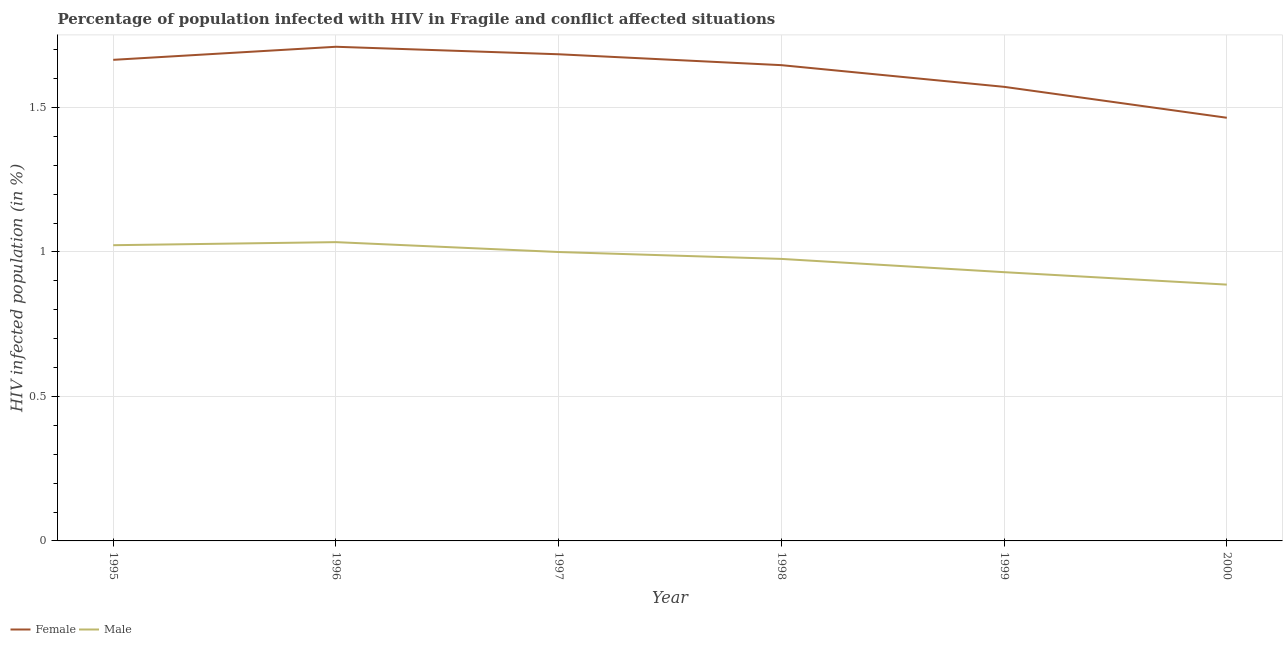How many different coloured lines are there?
Ensure brevity in your answer.  2. Does the line corresponding to percentage of females who are infected with hiv intersect with the line corresponding to percentage of males who are infected with hiv?
Offer a very short reply. No. Is the number of lines equal to the number of legend labels?
Your answer should be very brief. Yes. What is the percentage of males who are infected with hiv in 1998?
Provide a short and direct response. 0.98. Across all years, what is the maximum percentage of males who are infected with hiv?
Your response must be concise. 1.03. Across all years, what is the minimum percentage of males who are infected with hiv?
Your answer should be very brief. 0.89. In which year was the percentage of females who are infected with hiv maximum?
Give a very brief answer. 1996. What is the total percentage of males who are infected with hiv in the graph?
Ensure brevity in your answer.  5.85. What is the difference between the percentage of females who are infected with hiv in 1997 and that in 2000?
Offer a terse response. 0.22. What is the difference between the percentage of males who are infected with hiv in 1999 and the percentage of females who are infected with hiv in 1997?
Offer a terse response. -0.75. What is the average percentage of males who are infected with hiv per year?
Your answer should be very brief. 0.97. In the year 1999, what is the difference between the percentage of females who are infected with hiv and percentage of males who are infected with hiv?
Keep it short and to the point. 0.64. In how many years, is the percentage of females who are infected with hiv greater than 1.4 %?
Your response must be concise. 6. What is the ratio of the percentage of males who are infected with hiv in 1998 to that in 1999?
Give a very brief answer. 1.05. Is the percentage of males who are infected with hiv in 1996 less than that in 2000?
Keep it short and to the point. No. What is the difference between the highest and the second highest percentage of females who are infected with hiv?
Provide a succinct answer. 0.03. What is the difference between the highest and the lowest percentage of males who are infected with hiv?
Give a very brief answer. 0.15. In how many years, is the percentage of males who are infected with hiv greater than the average percentage of males who are infected with hiv taken over all years?
Make the answer very short. 4. Is the percentage of males who are infected with hiv strictly greater than the percentage of females who are infected with hiv over the years?
Your response must be concise. No. What is the difference between two consecutive major ticks on the Y-axis?
Keep it short and to the point. 0.5. Does the graph contain any zero values?
Provide a short and direct response. No. How are the legend labels stacked?
Give a very brief answer. Horizontal. What is the title of the graph?
Offer a terse response. Percentage of population infected with HIV in Fragile and conflict affected situations. What is the label or title of the X-axis?
Keep it short and to the point. Year. What is the label or title of the Y-axis?
Keep it short and to the point. HIV infected population (in %). What is the HIV infected population (in %) of Female in 1995?
Offer a terse response. 1.66. What is the HIV infected population (in %) of Male in 1995?
Keep it short and to the point. 1.02. What is the HIV infected population (in %) of Female in 1996?
Provide a short and direct response. 1.71. What is the HIV infected population (in %) in Male in 1996?
Make the answer very short. 1.03. What is the HIV infected population (in %) in Female in 1997?
Offer a very short reply. 1.68. What is the HIV infected population (in %) in Male in 1997?
Make the answer very short. 1. What is the HIV infected population (in %) of Female in 1998?
Your answer should be compact. 1.65. What is the HIV infected population (in %) of Male in 1998?
Offer a terse response. 0.98. What is the HIV infected population (in %) in Female in 1999?
Offer a terse response. 1.57. What is the HIV infected population (in %) of Male in 1999?
Your answer should be very brief. 0.93. What is the HIV infected population (in %) in Female in 2000?
Give a very brief answer. 1.46. What is the HIV infected population (in %) of Male in 2000?
Keep it short and to the point. 0.89. Across all years, what is the maximum HIV infected population (in %) of Female?
Your response must be concise. 1.71. Across all years, what is the maximum HIV infected population (in %) in Male?
Your response must be concise. 1.03. Across all years, what is the minimum HIV infected population (in %) in Female?
Keep it short and to the point. 1.46. Across all years, what is the minimum HIV infected population (in %) of Male?
Make the answer very short. 0.89. What is the total HIV infected population (in %) of Female in the graph?
Offer a very short reply. 9.74. What is the total HIV infected population (in %) of Male in the graph?
Ensure brevity in your answer.  5.85. What is the difference between the HIV infected population (in %) in Female in 1995 and that in 1996?
Keep it short and to the point. -0.05. What is the difference between the HIV infected population (in %) in Male in 1995 and that in 1996?
Offer a terse response. -0.01. What is the difference between the HIV infected population (in %) of Female in 1995 and that in 1997?
Your answer should be compact. -0.02. What is the difference between the HIV infected population (in %) in Male in 1995 and that in 1997?
Keep it short and to the point. 0.02. What is the difference between the HIV infected population (in %) in Female in 1995 and that in 1998?
Offer a terse response. 0.02. What is the difference between the HIV infected population (in %) in Male in 1995 and that in 1998?
Your answer should be compact. 0.05. What is the difference between the HIV infected population (in %) of Female in 1995 and that in 1999?
Your response must be concise. 0.09. What is the difference between the HIV infected population (in %) in Male in 1995 and that in 1999?
Make the answer very short. 0.09. What is the difference between the HIV infected population (in %) of Female in 1995 and that in 2000?
Offer a very short reply. 0.2. What is the difference between the HIV infected population (in %) in Male in 1995 and that in 2000?
Offer a very short reply. 0.14. What is the difference between the HIV infected population (in %) of Female in 1996 and that in 1997?
Provide a succinct answer. 0.03. What is the difference between the HIV infected population (in %) in Male in 1996 and that in 1997?
Your answer should be compact. 0.03. What is the difference between the HIV infected population (in %) in Female in 1996 and that in 1998?
Offer a terse response. 0.06. What is the difference between the HIV infected population (in %) in Male in 1996 and that in 1998?
Ensure brevity in your answer.  0.06. What is the difference between the HIV infected population (in %) in Female in 1996 and that in 1999?
Provide a short and direct response. 0.14. What is the difference between the HIV infected population (in %) of Male in 1996 and that in 1999?
Provide a short and direct response. 0.1. What is the difference between the HIV infected population (in %) in Female in 1996 and that in 2000?
Give a very brief answer. 0.25. What is the difference between the HIV infected population (in %) in Male in 1996 and that in 2000?
Give a very brief answer. 0.15. What is the difference between the HIV infected population (in %) in Female in 1997 and that in 1998?
Make the answer very short. 0.04. What is the difference between the HIV infected population (in %) in Male in 1997 and that in 1998?
Your answer should be compact. 0.02. What is the difference between the HIV infected population (in %) in Female in 1997 and that in 1999?
Provide a succinct answer. 0.11. What is the difference between the HIV infected population (in %) of Male in 1997 and that in 1999?
Your answer should be compact. 0.07. What is the difference between the HIV infected population (in %) of Female in 1997 and that in 2000?
Your answer should be compact. 0.22. What is the difference between the HIV infected population (in %) of Male in 1997 and that in 2000?
Make the answer very short. 0.11. What is the difference between the HIV infected population (in %) in Female in 1998 and that in 1999?
Keep it short and to the point. 0.07. What is the difference between the HIV infected population (in %) in Male in 1998 and that in 1999?
Your answer should be compact. 0.05. What is the difference between the HIV infected population (in %) of Female in 1998 and that in 2000?
Provide a short and direct response. 0.18. What is the difference between the HIV infected population (in %) in Male in 1998 and that in 2000?
Provide a succinct answer. 0.09. What is the difference between the HIV infected population (in %) of Female in 1999 and that in 2000?
Provide a succinct answer. 0.11. What is the difference between the HIV infected population (in %) in Male in 1999 and that in 2000?
Your answer should be compact. 0.04. What is the difference between the HIV infected population (in %) of Female in 1995 and the HIV infected population (in %) of Male in 1996?
Your answer should be very brief. 0.63. What is the difference between the HIV infected population (in %) of Female in 1995 and the HIV infected population (in %) of Male in 1997?
Keep it short and to the point. 0.67. What is the difference between the HIV infected population (in %) of Female in 1995 and the HIV infected population (in %) of Male in 1998?
Make the answer very short. 0.69. What is the difference between the HIV infected population (in %) in Female in 1995 and the HIV infected population (in %) in Male in 1999?
Give a very brief answer. 0.73. What is the difference between the HIV infected population (in %) of Female in 1996 and the HIV infected population (in %) of Male in 1997?
Your answer should be very brief. 0.71. What is the difference between the HIV infected population (in %) in Female in 1996 and the HIV infected population (in %) in Male in 1998?
Offer a very short reply. 0.73. What is the difference between the HIV infected population (in %) of Female in 1996 and the HIV infected population (in %) of Male in 1999?
Ensure brevity in your answer.  0.78. What is the difference between the HIV infected population (in %) of Female in 1996 and the HIV infected population (in %) of Male in 2000?
Provide a succinct answer. 0.82. What is the difference between the HIV infected population (in %) of Female in 1997 and the HIV infected population (in %) of Male in 1998?
Give a very brief answer. 0.71. What is the difference between the HIV infected population (in %) in Female in 1997 and the HIV infected population (in %) in Male in 1999?
Provide a succinct answer. 0.75. What is the difference between the HIV infected population (in %) in Female in 1997 and the HIV infected population (in %) in Male in 2000?
Your response must be concise. 0.8. What is the difference between the HIV infected population (in %) in Female in 1998 and the HIV infected population (in %) in Male in 1999?
Your response must be concise. 0.72. What is the difference between the HIV infected population (in %) in Female in 1998 and the HIV infected population (in %) in Male in 2000?
Provide a short and direct response. 0.76. What is the difference between the HIV infected population (in %) in Female in 1999 and the HIV infected population (in %) in Male in 2000?
Give a very brief answer. 0.68. What is the average HIV infected population (in %) in Female per year?
Provide a succinct answer. 1.62. What is the average HIV infected population (in %) in Male per year?
Offer a terse response. 0.97. In the year 1995, what is the difference between the HIV infected population (in %) in Female and HIV infected population (in %) in Male?
Your answer should be very brief. 0.64. In the year 1996, what is the difference between the HIV infected population (in %) in Female and HIV infected population (in %) in Male?
Make the answer very short. 0.68. In the year 1997, what is the difference between the HIV infected population (in %) in Female and HIV infected population (in %) in Male?
Offer a very short reply. 0.68. In the year 1998, what is the difference between the HIV infected population (in %) in Female and HIV infected population (in %) in Male?
Your answer should be very brief. 0.67. In the year 1999, what is the difference between the HIV infected population (in %) in Female and HIV infected population (in %) in Male?
Provide a short and direct response. 0.64. In the year 2000, what is the difference between the HIV infected population (in %) of Female and HIV infected population (in %) of Male?
Keep it short and to the point. 0.58. What is the ratio of the HIV infected population (in %) in Female in 1995 to that in 1996?
Provide a succinct answer. 0.97. What is the ratio of the HIV infected population (in %) in Male in 1995 to that in 1996?
Your answer should be very brief. 0.99. What is the ratio of the HIV infected population (in %) of Male in 1995 to that in 1997?
Provide a short and direct response. 1.02. What is the ratio of the HIV infected population (in %) in Female in 1995 to that in 1998?
Provide a short and direct response. 1.01. What is the ratio of the HIV infected population (in %) of Male in 1995 to that in 1998?
Your answer should be very brief. 1.05. What is the ratio of the HIV infected population (in %) of Female in 1995 to that in 1999?
Provide a short and direct response. 1.06. What is the ratio of the HIV infected population (in %) in Male in 1995 to that in 1999?
Ensure brevity in your answer.  1.1. What is the ratio of the HIV infected population (in %) of Female in 1995 to that in 2000?
Offer a very short reply. 1.14. What is the ratio of the HIV infected population (in %) in Male in 1995 to that in 2000?
Offer a terse response. 1.15. What is the ratio of the HIV infected population (in %) in Female in 1996 to that in 1997?
Make the answer very short. 1.02. What is the ratio of the HIV infected population (in %) of Male in 1996 to that in 1997?
Offer a terse response. 1.03. What is the ratio of the HIV infected population (in %) in Female in 1996 to that in 1998?
Your response must be concise. 1.04. What is the ratio of the HIV infected population (in %) of Male in 1996 to that in 1998?
Make the answer very short. 1.06. What is the ratio of the HIV infected population (in %) of Female in 1996 to that in 1999?
Provide a short and direct response. 1.09. What is the ratio of the HIV infected population (in %) in Male in 1996 to that in 1999?
Your response must be concise. 1.11. What is the ratio of the HIV infected population (in %) of Female in 1996 to that in 2000?
Your response must be concise. 1.17. What is the ratio of the HIV infected population (in %) in Male in 1996 to that in 2000?
Your answer should be very brief. 1.17. What is the ratio of the HIV infected population (in %) in Female in 1997 to that in 1998?
Offer a terse response. 1.02. What is the ratio of the HIV infected population (in %) in Male in 1997 to that in 1998?
Make the answer very short. 1.02. What is the ratio of the HIV infected population (in %) in Female in 1997 to that in 1999?
Offer a terse response. 1.07. What is the ratio of the HIV infected population (in %) in Male in 1997 to that in 1999?
Give a very brief answer. 1.07. What is the ratio of the HIV infected population (in %) in Female in 1997 to that in 2000?
Offer a very short reply. 1.15. What is the ratio of the HIV infected population (in %) of Male in 1997 to that in 2000?
Keep it short and to the point. 1.13. What is the ratio of the HIV infected population (in %) in Female in 1998 to that in 1999?
Offer a very short reply. 1.05. What is the ratio of the HIV infected population (in %) in Male in 1998 to that in 1999?
Provide a succinct answer. 1.05. What is the ratio of the HIV infected population (in %) in Female in 1998 to that in 2000?
Your answer should be very brief. 1.12. What is the ratio of the HIV infected population (in %) of Male in 1998 to that in 2000?
Provide a short and direct response. 1.1. What is the ratio of the HIV infected population (in %) of Female in 1999 to that in 2000?
Offer a very short reply. 1.07. What is the ratio of the HIV infected population (in %) of Male in 1999 to that in 2000?
Your answer should be very brief. 1.05. What is the difference between the highest and the second highest HIV infected population (in %) in Female?
Offer a very short reply. 0.03. What is the difference between the highest and the second highest HIV infected population (in %) in Male?
Provide a succinct answer. 0.01. What is the difference between the highest and the lowest HIV infected population (in %) in Female?
Ensure brevity in your answer.  0.25. What is the difference between the highest and the lowest HIV infected population (in %) of Male?
Give a very brief answer. 0.15. 